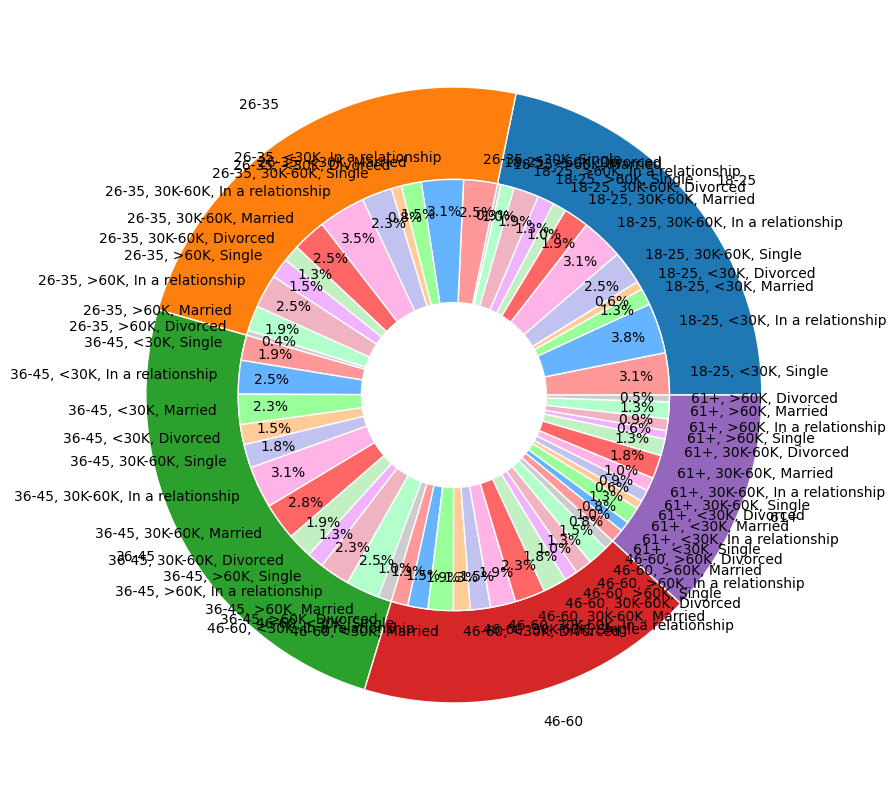What proportion of clients aged 18-25 have an income greater than 60K and are in a relationship? First, locate the section for age group 18-25. Within this age group, find the subsegment for income >60K. Among this subgroup, identify the count of clients who are 'In a relationship'. The count is 15. Sum all counts for the age group 18-25, which is 168. The proportion is 15/168 ≈ 0.089, or 8.9%.
Answer: 8.9% Compare the number of single clients between age groups 36-45 and 46-60 for the income group 30K-60K. Which age group has more single clients? Locate the age groups 36-45 and 46-60 on the pie chart. Within each age group, find the segment for income group 30K-60K. Compare the count of 'Single' clients in both segments: 36-45 has 14 single clients, while 46-60 has 12. Age group 36-45 has more single clients.
Answer: Age group 36-45 Which age group has the highest percentage of clients earning less than 30K and are divorced? For each age group, locate the segment corresponding to an income less than 30K and further the 'Divorced' status. Compare the counts: 18-25 (5), 26-35 (6), 36-45 (12), 46-60 (10), and 61+ (5). Age group 36-45 has the highest count. Verify the total counts for each age group and calculate the percentage: 36-45 has 65 total, thus the percentage is 12/65 ≈ 18.5%.
Answer: 36-45 What are the visual differences between the segments of married clients with incomes over 60K across different age groups? Identify the segments for 'Married' clients with income over 60K for each age group: 18-25, 26-35, 36-45, 46-60, and 61+. Note the segment sizes and colors for visual differences. The counts are 8, 15, 20, 12, and 10 respectively. Ages 36-45 appears largest visually.
Answer: Ages 36-45 appears largest visually What is the total number of clients in a relationship aged between 26-35 across all income groups? Locate the age group 26-35. Sum the counts of 'In a relationship' across all income groups within this age bracket: <30K (25), 30K-60K (28), and >60K (20). The total is 25 + 28 + 20 = 73.
Answer: 73 Among clients aged 61+, which income group has the greatest number of married clients? Locate the age group 61+. Identify and compare the counts of 'Married' clients across all income groups: <30K (10), 30K-60K (14), and >60K (10). The income group 30K-60K has the greatest number.
Answer: 30K-60K Considering all segmented groups, which relationship status appears most frequently in the age group 18-25? Examine the segments within age group 18-25 for all relationship statuses. Sum the counts for each status: Single (55), In a relationship (70), Married (33), Divorced (15). The status 'In a relationship' appears most frequently.
Answer: In a relationship What is the ratio of single to married clients aged 36-45 for income group 30K-60K? Locate the age group 36-45. Identify the segments for income 30K-60K and find counts of 'Single' and 'Married' clients: 14 and 22 respectively. The ratio is 14/22 = 7/11.
Answer: 7:11 